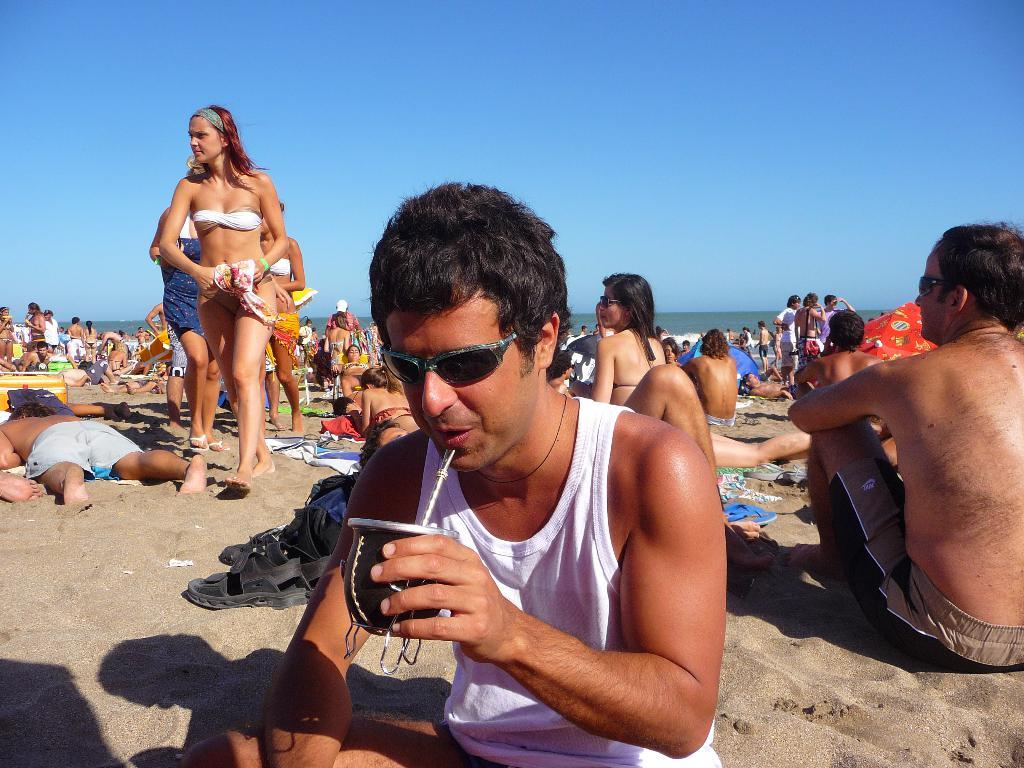What is the man in the image doing? The man is sitting in the image and drinking something. Can you describe the background of the image? There are people in the background of the image. What is visible at the top of the image? The sky is visible at the top of the image. What type of song is the frog singing in the image? There is no frog or song present in the image. Where is the oven located in the image? There is no oven present in the image. 